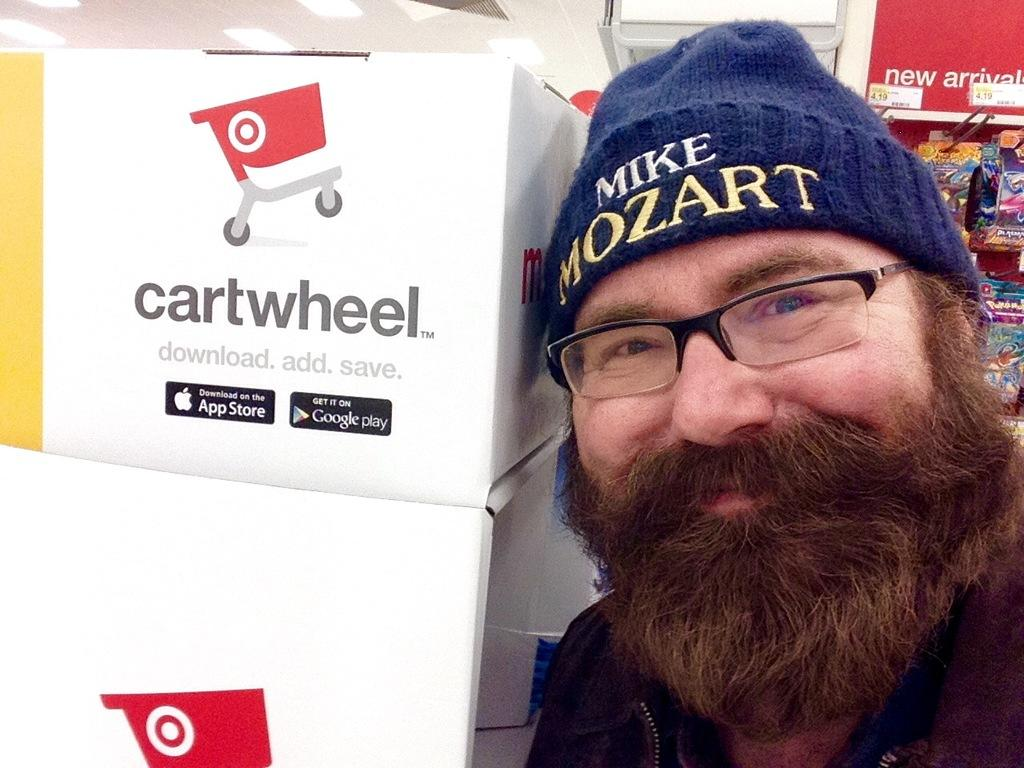Who is present in the image? There is a man in the image. Where is the man located in the image? The man is on the right side of the image. What objects are in front of the man? There are carton boxes in front of the man. What can be seen hanging in the top right corner of the image? Food packets are hanging on a pole in the top right corner of the image. What type of ornament is hanging from the man's neck in the image? There is no ornament hanging from the man's neck in the image. Can you tell me how many receipts are visible in the image? There are no receipts visible in the image. 